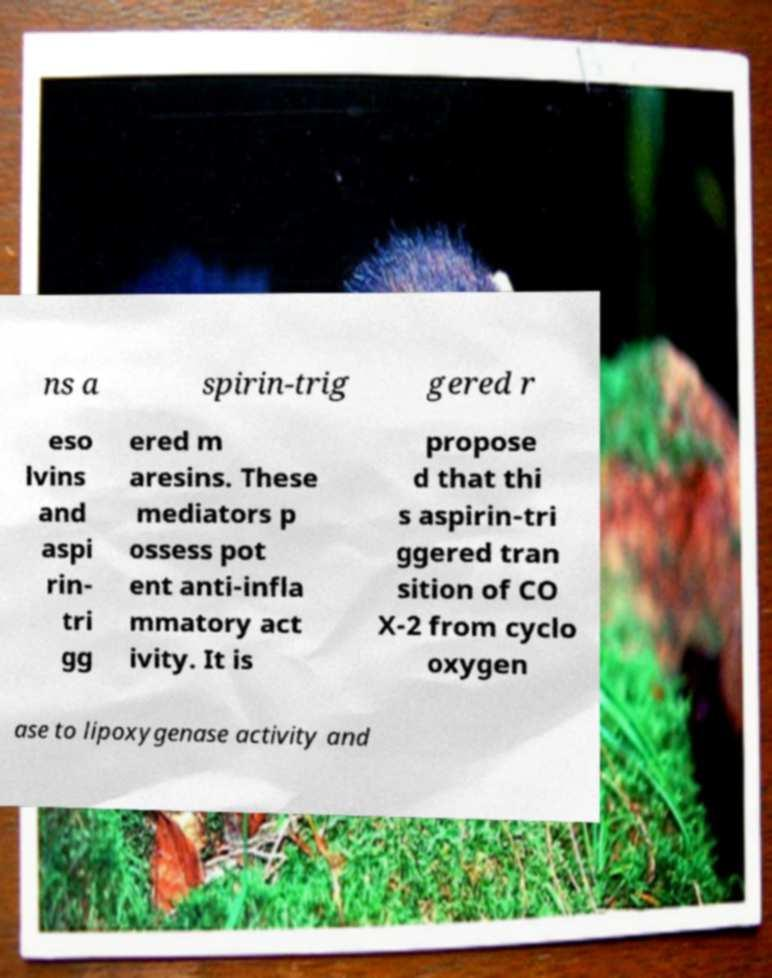There's text embedded in this image that I need extracted. Can you transcribe it verbatim? ns a spirin-trig gered r eso lvins and aspi rin- tri gg ered m aresins. These mediators p ossess pot ent anti-infla mmatory act ivity. It is propose d that thi s aspirin-tri ggered tran sition of CO X-2 from cyclo oxygen ase to lipoxygenase activity and 